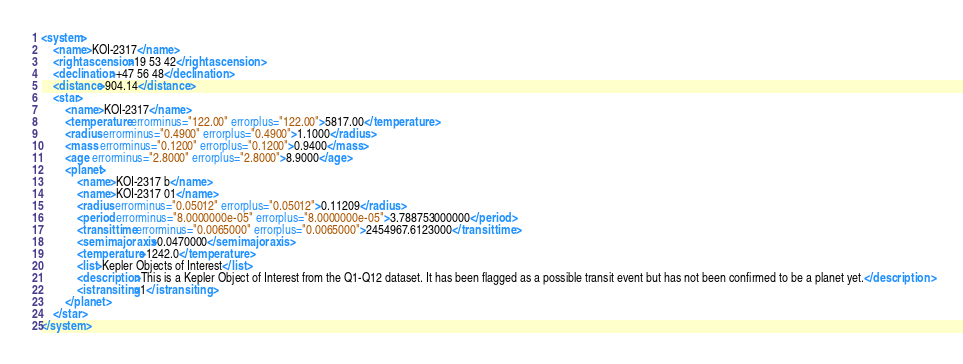Convert code to text. <code><loc_0><loc_0><loc_500><loc_500><_XML_><system>
	<name>KOI-2317</name>
	<rightascension>19 53 42</rightascension>
	<declination>+47 56 48</declination>
	<distance>904.14</distance>
	<star>
		<name>KOI-2317</name>
		<temperature errorminus="122.00" errorplus="122.00">5817.00</temperature>
		<radius errorminus="0.4900" errorplus="0.4900">1.1000</radius>
		<mass errorminus="0.1200" errorplus="0.1200">0.9400</mass>
		<age errorminus="2.8000" errorplus="2.8000">8.9000</age>
		<planet>
			<name>KOI-2317 b</name>
			<name>KOI-2317 01</name>
			<radius errorminus="0.05012" errorplus="0.05012">0.11209</radius>
			<period errorminus="8.0000000e-05" errorplus="8.0000000e-05">3.788753000000</period>
			<transittime errorminus="0.0065000" errorplus="0.0065000">2454967.6123000</transittime>
			<semimajoraxis>0.0470000</semimajoraxis>
			<temperature>1242.0</temperature>
			<list>Kepler Objects of Interest</list>
			<description>This is a Kepler Object of Interest from the Q1-Q12 dataset. It has been flagged as a possible transit event but has not been confirmed to be a planet yet.</description>
			<istransiting>1</istransiting>
		</planet>
	</star>
</system>
</code> 